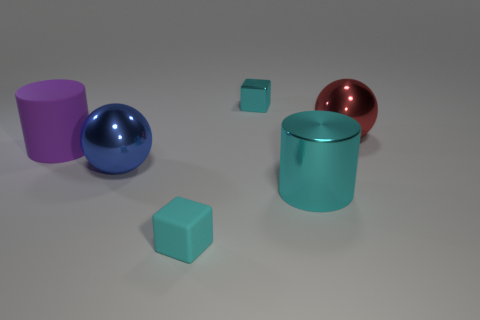Is there a cyan metallic block that has the same size as the cyan metallic cylinder? no 